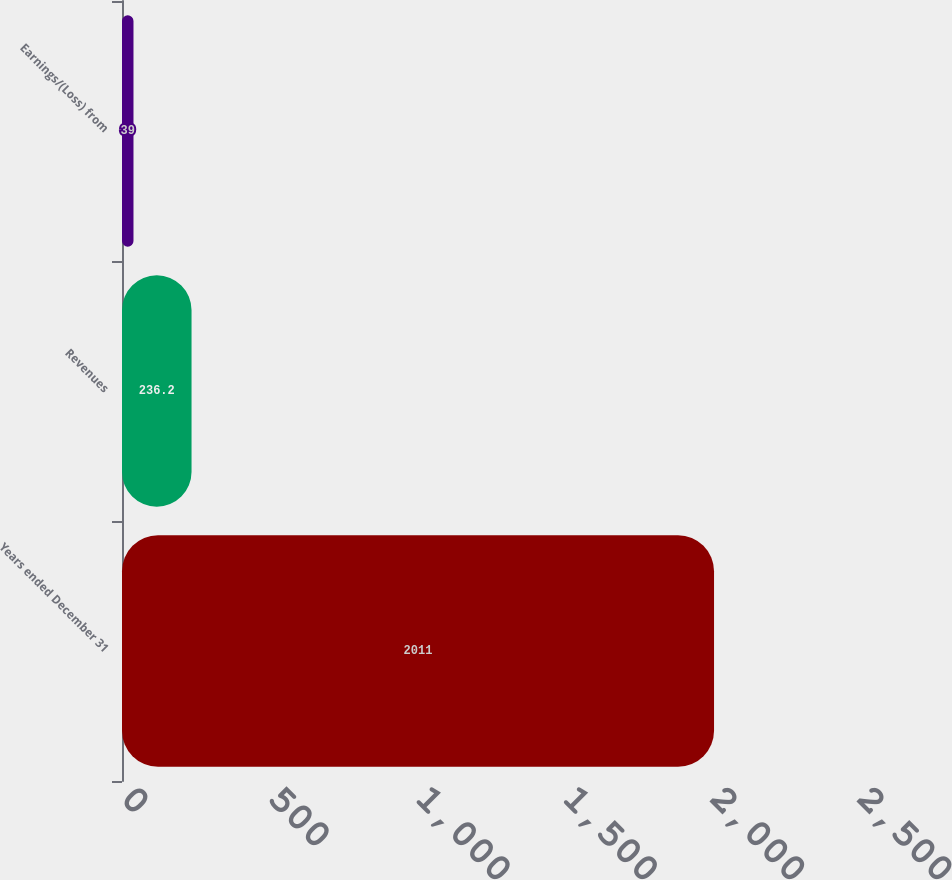Convert chart to OTSL. <chart><loc_0><loc_0><loc_500><loc_500><bar_chart><fcel>Years ended December 31<fcel>Revenues<fcel>Earnings/(Loss) from<nl><fcel>2011<fcel>236.2<fcel>39<nl></chart> 